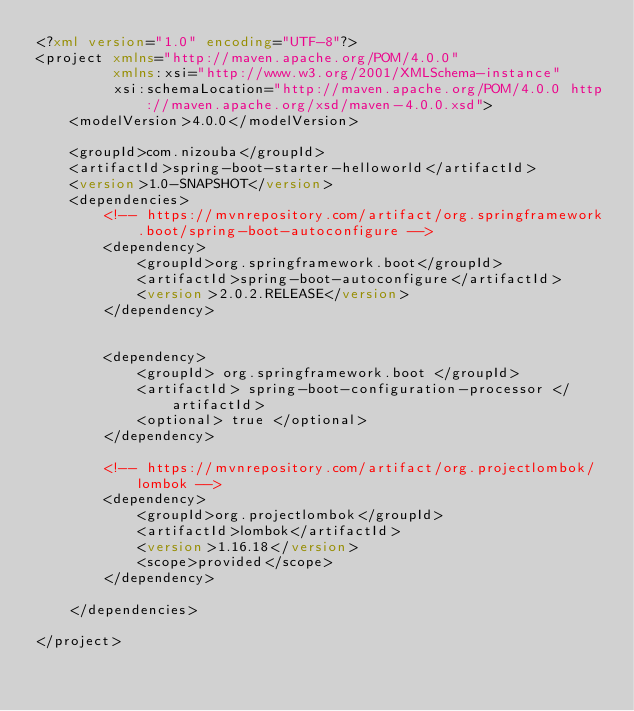<code> <loc_0><loc_0><loc_500><loc_500><_XML_><?xml version="1.0" encoding="UTF-8"?>
<project xmlns="http://maven.apache.org/POM/4.0.0"
         xmlns:xsi="http://www.w3.org/2001/XMLSchema-instance"
         xsi:schemaLocation="http://maven.apache.org/POM/4.0.0 http://maven.apache.org/xsd/maven-4.0.0.xsd">
    <modelVersion>4.0.0</modelVersion>

    <groupId>com.nizouba</groupId>
    <artifactId>spring-boot-starter-helloworld</artifactId>
    <version>1.0-SNAPSHOT</version>
    <dependencies>
        <!-- https://mvnrepository.com/artifact/org.springframework.boot/spring-boot-autoconfigure -->
        <dependency>
            <groupId>org.springframework.boot</groupId>
            <artifactId>spring-boot-autoconfigure</artifactId>
            <version>2.0.2.RELEASE</version>
        </dependency>


        <dependency>
            <groupId> org.springframework.boot </groupId>
            <artifactId> spring-boot-configuration-processor </artifactId>
            <optional> true </optional>
        </dependency>

        <!-- https://mvnrepository.com/artifact/org.projectlombok/lombok -->
        <dependency>
            <groupId>org.projectlombok</groupId>
            <artifactId>lombok</artifactId>
            <version>1.16.18</version>
            <scope>provided</scope>
        </dependency>

    </dependencies>

</project></code> 